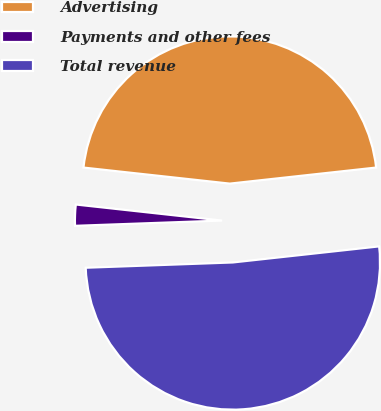Convert chart. <chart><loc_0><loc_0><loc_500><loc_500><pie_chart><fcel>Advertising<fcel>Payments and other fees<fcel>Total revenue<nl><fcel>46.52%<fcel>2.31%<fcel>51.17%<nl></chart> 